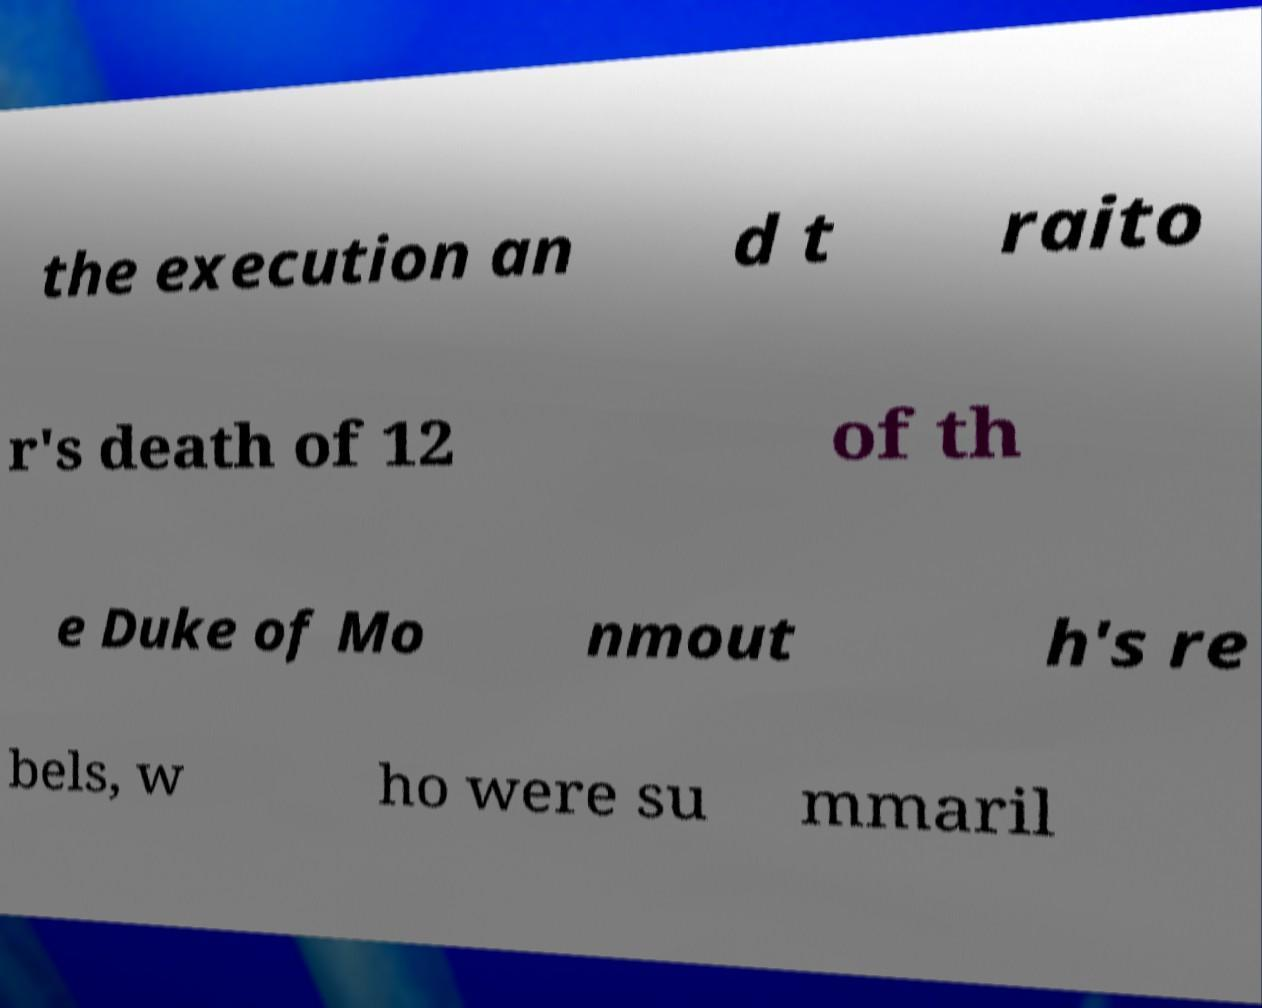Please read and relay the text visible in this image. What does it say? the execution an d t raito r's death of 12 of th e Duke of Mo nmout h's re bels, w ho were su mmaril 